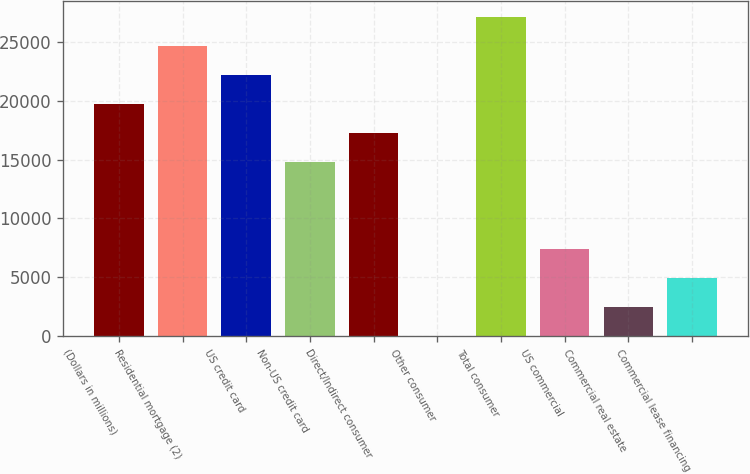Convert chart. <chart><loc_0><loc_0><loc_500><loc_500><bar_chart><fcel>(Dollars in millions)<fcel>Residential mortgage (2)<fcel>US credit card<fcel>Non-US credit card<fcel>Direct/Indirect consumer<fcel>Other consumer<fcel>Total consumer<fcel>US commercial<fcel>Commercial real estate<fcel>Commercial lease financing<nl><fcel>19709.2<fcel>24636<fcel>22172.6<fcel>14782.4<fcel>17245.8<fcel>2<fcel>27099.4<fcel>7392.2<fcel>2465.4<fcel>4928.8<nl></chart> 